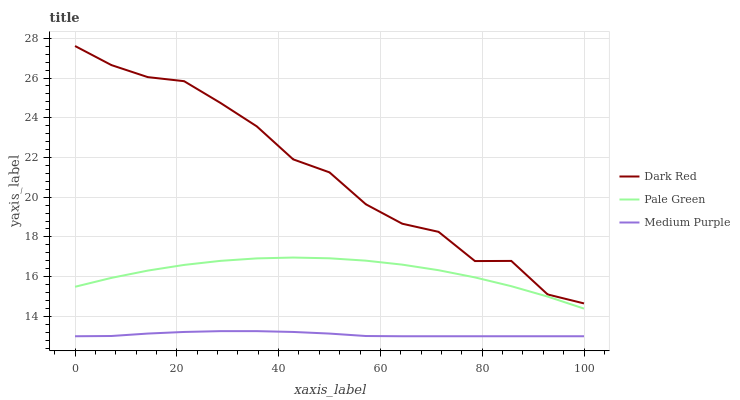Does Medium Purple have the minimum area under the curve?
Answer yes or no. Yes. Does Dark Red have the maximum area under the curve?
Answer yes or no. Yes. Does Pale Green have the minimum area under the curve?
Answer yes or no. No. Does Pale Green have the maximum area under the curve?
Answer yes or no. No. Is Medium Purple the smoothest?
Answer yes or no. Yes. Is Dark Red the roughest?
Answer yes or no. Yes. Is Pale Green the smoothest?
Answer yes or no. No. Is Pale Green the roughest?
Answer yes or no. No. Does Medium Purple have the lowest value?
Answer yes or no. Yes. Does Pale Green have the lowest value?
Answer yes or no. No. Does Dark Red have the highest value?
Answer yes or no. Yes. Does Pale Green have the highest value?
Answer yes or no. No. Is Medium Purple less than Pale Green?
Answer yes or no. Yes. Is Dark Red greater than Pale Green?
Answer yes or no. Yes. Does Medium Purple intersect Pale Green?
Answer yes or no. No. 